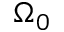Convert formula to latex. <formula><loc_0><loc_0><loc_500><loc_500>\Omega _ { 0 }</formula> 